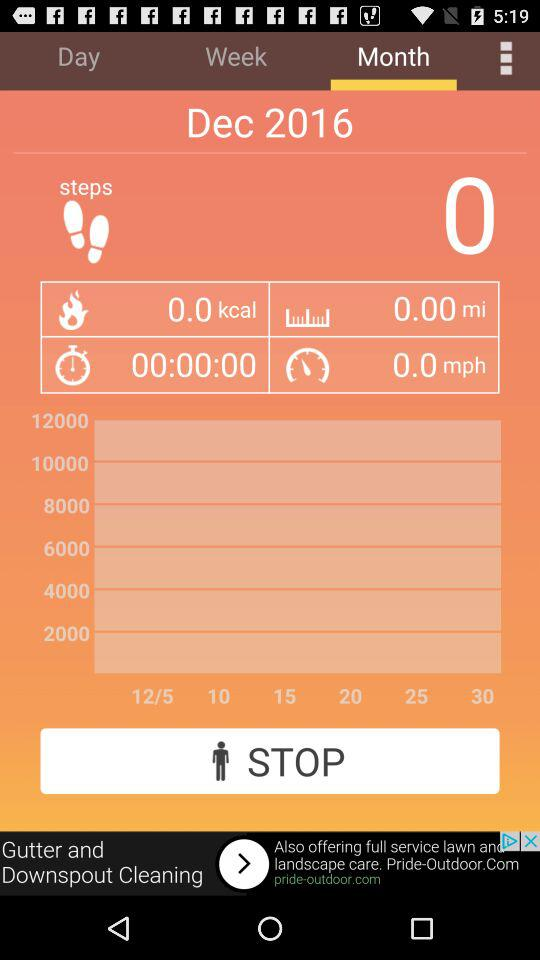Which tab is selected? The selected tab is "Month". 